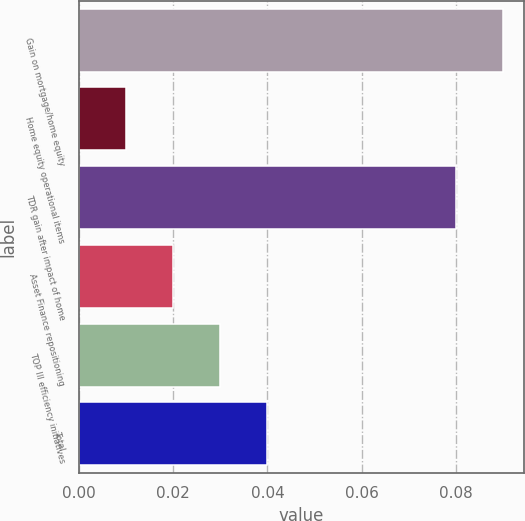Convert chart to OTSL. <chart><loc_0><loc_0><loc_500><loc_500><bar_chart><fcel>Gain on mortgage/home equity<fcel>Home equity operational items<fcel>TDR gain after impact of home<fcel>Asset Finance repositioning<fcel>TOP III efficiency initiatives<fcel>Total<nl><fcel>0.09<fcel>0.01<fcel>0.08<fcel>0.02<fcel>0.03<fcel>0.04<nl></chart> 